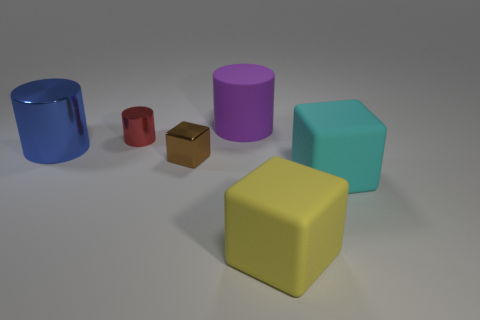What shape is the big object that is both on the left side of the big yellow rubber block and to the right of the blue metal cylinder?
Make the answer very short. Cylinder. Is the number of cyan blocks that are behind the big blue cylinder the same as the number of cyan rubber things left of the big cyan cube?
Provide a succinct answer. Yes. Do the big thing to the left of the big purple thing and the yellow thing have the same shape?
Provide a succinct answer. No. What number of red things are tiny blocks or big cubes?
Your answer should be very brief. 0. What is the material of the other big object that is the same shape as the big purple matte object?
Your answer should be compact. Metal. What is the shape of the big rubber object in front of the cyan block?
Your answer should be compact. Cube. Is there a purple cylinder that has the same material as the yellow thing?
Your answer should be compact. Yes. Do the yellow rubber object and the brown metal cube have the same size?
Your response must be concise. No. How many blocks are small red metal objects or cyan rubber objects?
Offer a very short reply. 1. What number of small things have the same shape as the large cyan matte object?
Your response must be concise. 1. 